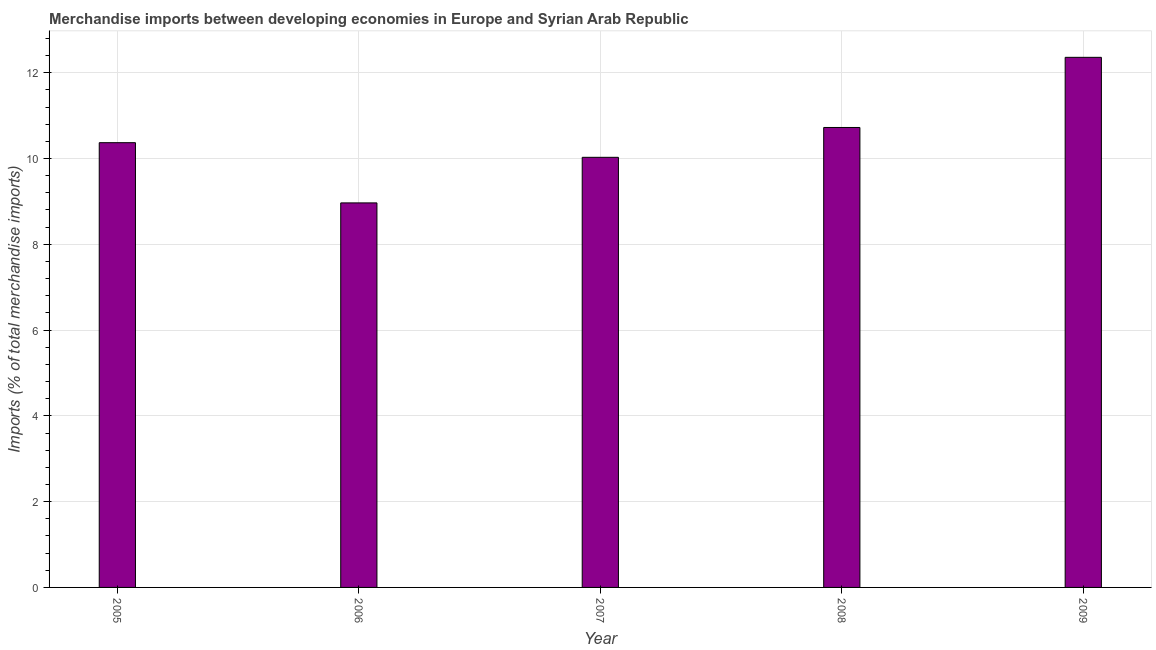Does the graph contain any zero values?
Provide a succinct answer. No. What is the title of the graph?
Make the answer very short. Merchandise imports between developing economies in Europe and Syrian Arab Republic. What is the label or title of the X-axis?
Give a very brief answer. Year. What is the label or title of the Y-axis?
Your answer should be very brief. Imports (% of total merchandise imports). What is the merchandise imports in 2009?
Make the answer very short. 12.36. Across all years, what is the maximum merchandise imports?
Offer a very short reply. 12.36. Across all years, what is the minimum merchandise imports?
Your answer should be compact. 8.96. In which year was the merchandise imports maximum?
Offer a terse response. 2009. What is the sum of the merchandise imports?
Keep it short and to the point. 52.44. What is the difference between the merchandise imports in 2007 and 2009?
Keep it short and to the point. -2.33. What is the average merchandise imports per year?
Offer a very short reply. 10.49. What is the median merchandise imports?
Your answer should be compact. 10.37. Do a majority of the years between 2009 and 2005 (inclusive) have merchandise imports greater than 4.8 %?
Offer a terse response. Yes. What is the ratio of the merchandise imports in 2006 to that in 2007?
Offer a very short reply. 0.89. What is the difference between the highest and the second highest merchandise imports?
Provide a succinct answer. 1.64. What is the difference between the highest and the lowest merchandise imports?
Your answer should be compact. 3.39. In how many years, is the merchandise imports greater than the average merchandise imports taken over all years?
Your response must be concise. 2. Are all the bars in the graph horizontal?
Your answer should be compact. No. How many years are there in the graph?
Offer a very short reply. 5. What is the Imports (% of total merchandise imports) of 2005?
Your answer should be very brief. 10.37. What is the Imports (% of total merchandise imports) in 2006?
Ensure brevity in your answer.  8.96. What is the Imports (% of total merchandise imports) in 2007?
Make the answer very short. 10.03. What is the Imports (% of total merchandise imports) in 2008?
Offer a terse response. 10.72. What is the Imports (% of total merchandise imports) in 2009?
Offer a very short reply. 12.36. What is the difference between the Imports (% of total merchandise imports) in 2005 and 2006?
Provide a short and direct response. 1.4. What is the difference between the Imports (% of total merchandise imports) in 2005 and 2007?
Your response must be concise. 0.34. What is the difference between the Imports (% of total merchandise imports) in 2005 and 2008?
Offer a very short reply. -0.35. What is the difference between the Imports (% of total merchandise imports) in 2005 and 2009?
Keep it short and to the point. -1.99. What is the difference between the Imports (% of total merchandise imports) in 2006 and 2007?
Offer a very short reply. -1.06. What is the difference between the Imports (% of total merchandise imports) in 2006 and 2008?
Provide a succinct answer. -1.76. What is the difference between the Imports (% of total merchandise imports) in 2006 and 2009?
Offer a terse response. -3.39. What is the difference between the Imports (% of total merchandise imports) in 2007 and 2008?
Your answer should be compact. -0.7. What is the difference between the Imports (% of total merchandise imports) in 2007 and 2009?
Your answer should be compact. -2.33. What is the difference between the Imports (% of total merchandise imports) in 2008 and 2009?
Your answer should be compact. -1.64. What is the ratio of the Imports (% of total merchandise imports) in 2005 to that in 2006?
Provide a short and direct response. 1.16. What is the ratio of the Imports (% of total merchandise imports) in 2005 to that in 2007?
Your answer should be compact. 1.03. What is the ratio of the Imports (% of total merchandise imports) in 2005 to that in 2008?
Offer a very short reply. 0.97. What is the ratio of the Imports (% of total merchandise imports) in 2005 to that in 2009?
Your response must be concise. 0.84. What is the ratio of the Imports (% of total merchandise imports) in 2006 to that in 2007?
Your response must be concise. 0.89. What is the ratio of the Imports (% of total merchandise imports) in 2006 to that in 2008?
Provide a short and direct response. 0.84. What is the ratio of the Imports (% of total merchandise imports) in 2006 to that in 2009?
Ensure brevity in your answer.  0.72. What is the ratio of the Imports (% of total merchandise imports) in 2007 to that in 2008?
Your response must be concise. 0.94. What is the ratio of the Imports (% of total merchandise imports) in 2007 to that in 2009?
Provide a short and direct response. 0.81. What is the ratio of the Imports (% of total merchandise imports) in 2008 to that in 2009?
Provide a short and direct response. 0.87. 